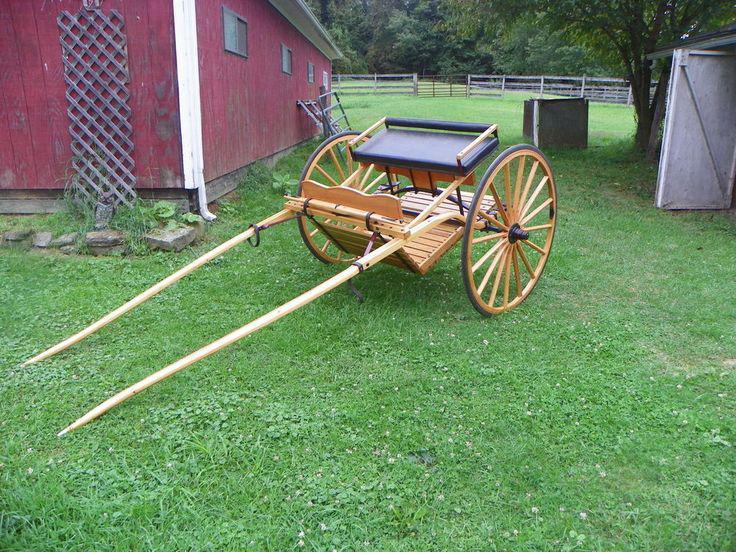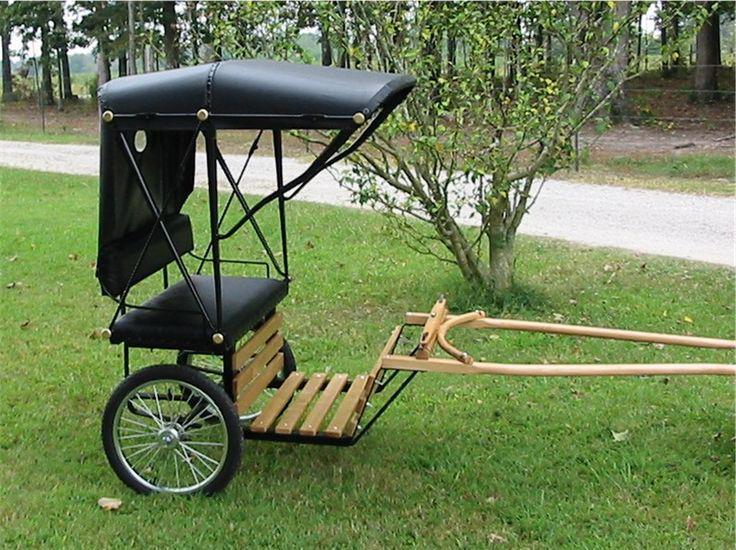The first image is the image on the left, the second image is the image on the right. Assess this claim about the two images: "A cart in one image is equipped with only two wheels on which are rubber tires.". Correct or not? Answer yes or no. Yes. 